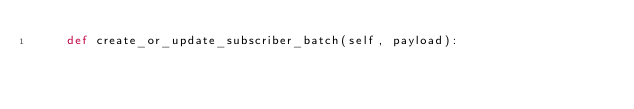<code> <loc_0><loc_0><loc_500><loc_500><_Python_>    def create_or_update_subscriber_batch(self, payload):</code> 